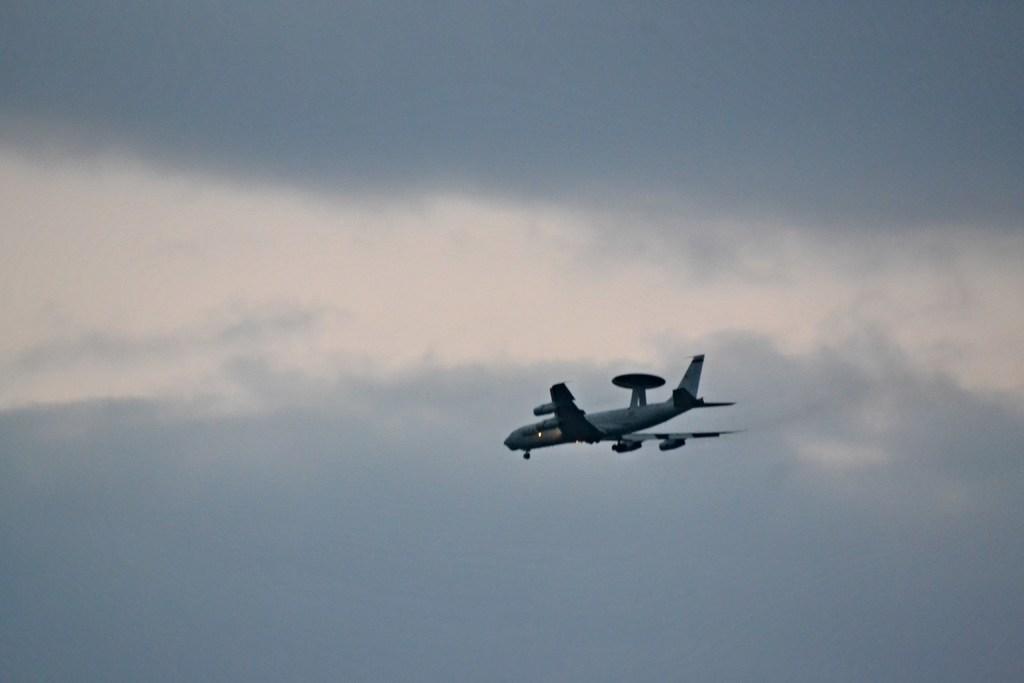Describe this image in one or two sentences. In this picture, we see the airplane is flying in the sky. In the background, we see the clouds and the sky, which is blue in color. 